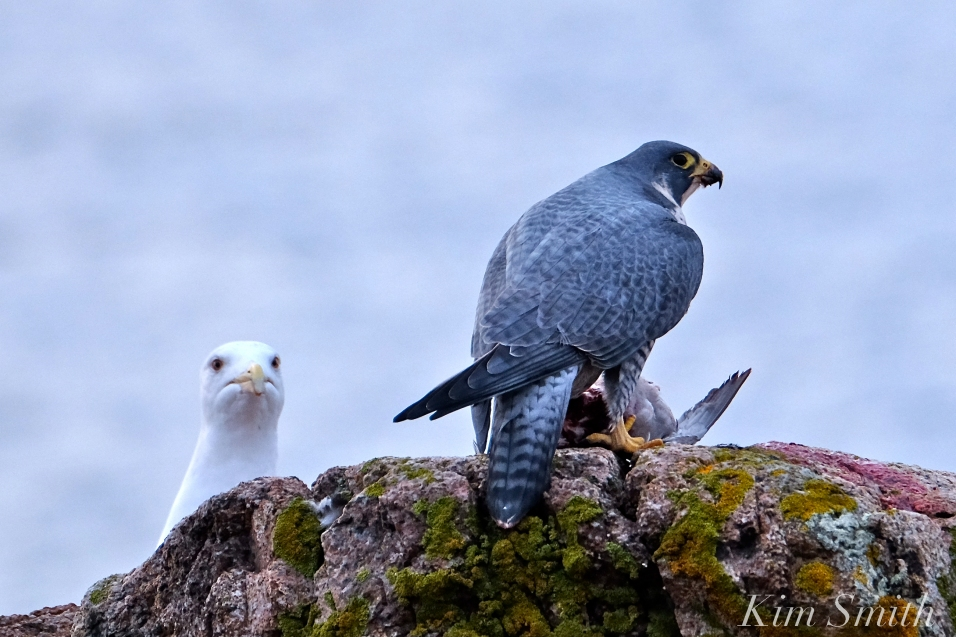How does the body language of the Peregrine Falcon contribute to understanding its behavior at the moment the photo was taken? The body language of the Peregrine Falcon provides significant insight into its current behavior. The falcon is perched on a rock, with its talons gripping its prey firmly, indicating that it has recently made a successful hunt. Its posture, with the back facing the open space and head turned to the side, reveals a state of vigilance, aware of its surroundings and potential threats. The orientation of the body and the slight opening of its beak can suggest that it is catching its breath after a strenuous hunt, or that it remains in a heightened state of alertness. The presence of the nearby gull watching the falcon suggests a competitive or cautious dynamic, as the falcon might be protecting its catch from being stolen. These observations highlight the falcon's protective, alert, and slightly defensive stance, typical of birds of prey securing their meal. 